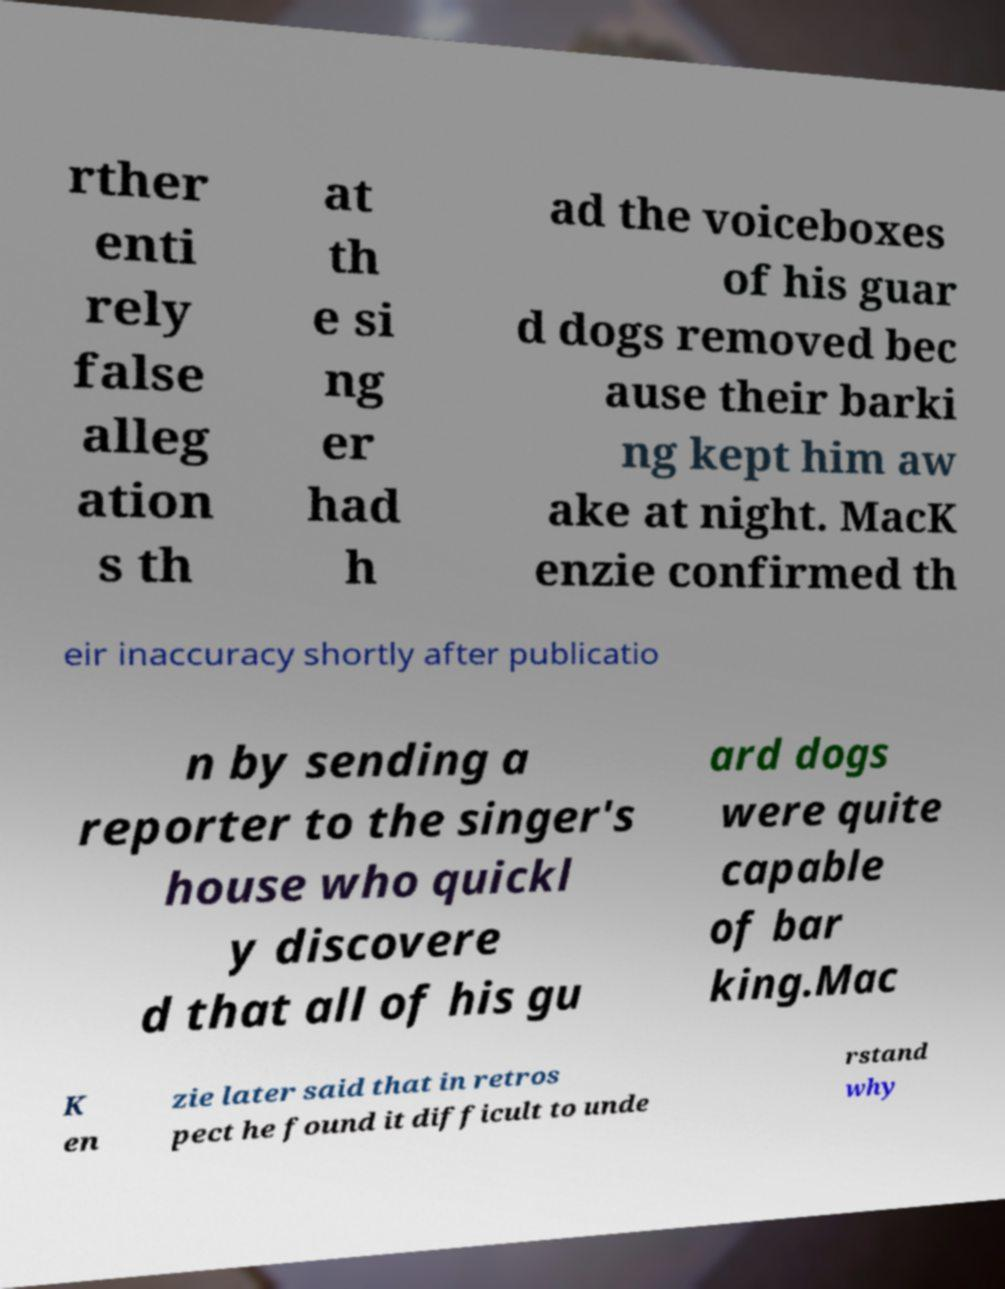Could you assist in decoding the text presented in this image and type it out clearly? rther enti rely false alleg ation s th at th e si ng er had h ad the voiceboxes of his guar d dogs removed bec ause their barki ng kept him aw ake at night. MacK enzie confirmed th eir inaccuracy shortly after publicatio n by sending a reporter to the singer's house who quickl y discovere d that all of his gu ard dogs were quite capable of bar king.Mac K en zie later said that in retros pect he found it difficult to unde rstand why 